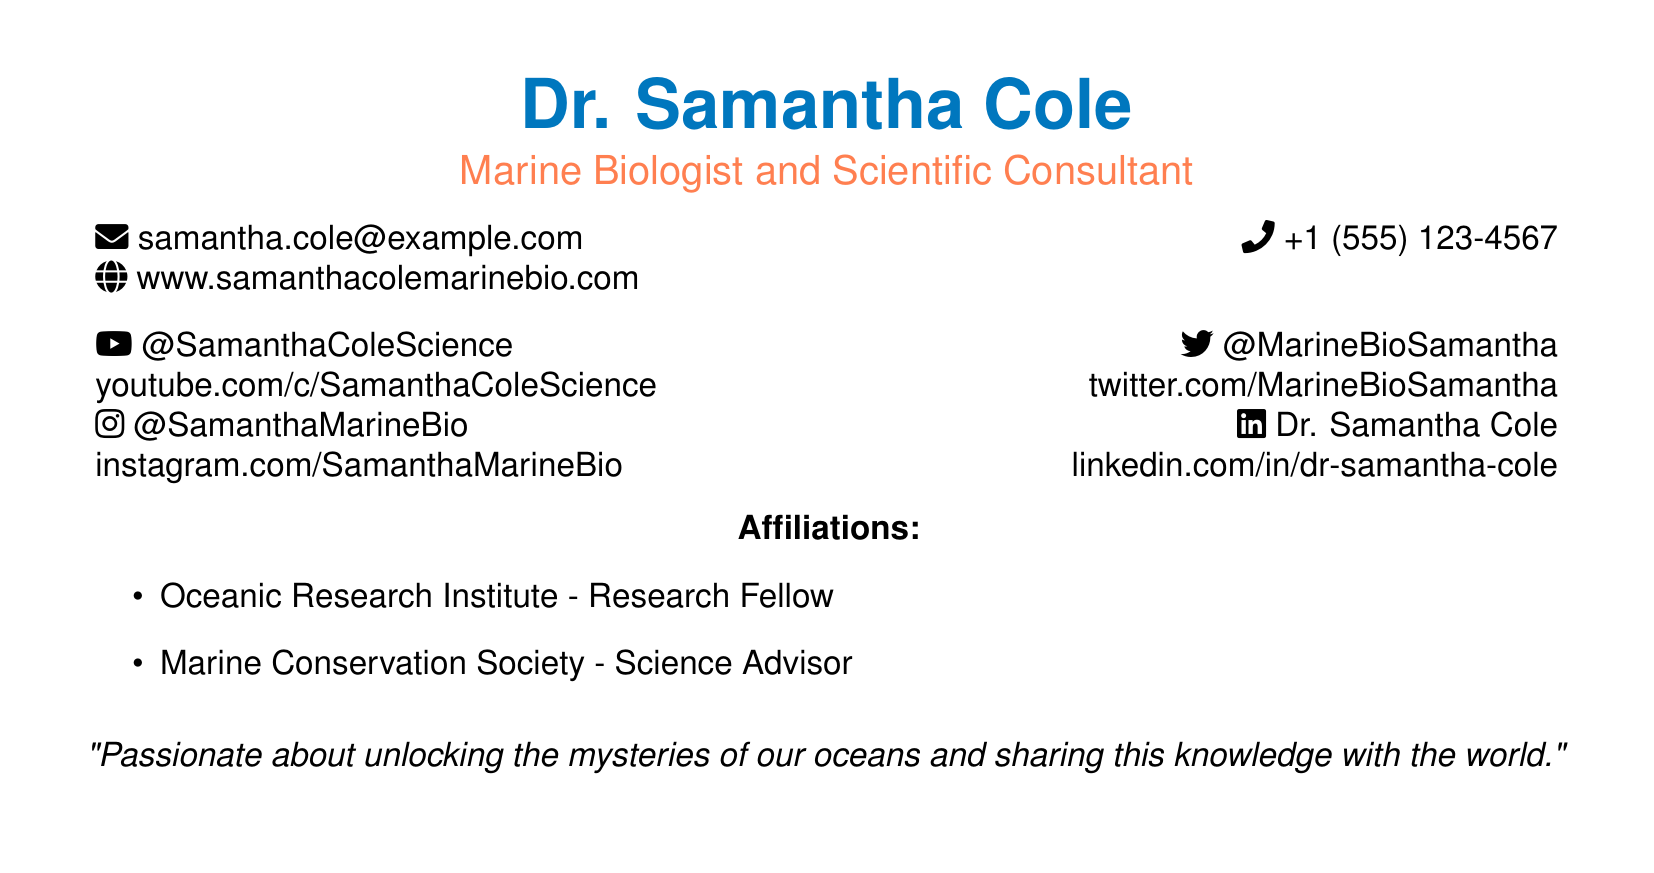What is the name of the marine biologist? The name is prominently displayed at the top of the document.
Answer: Dr. Samantha Cole What is the email address listed? The email address is located in the contact information section.
Answer: samantha.cole@example.com What is Dr. Samantha Cole's YouTube channel link? The YouTube channel link is found in the social media handles section.
Answer: youtube.com/c/SamanthaColeScience Which organization does Dr. Samantha Cole affiliate with as a research fellow? The document specifies affiliations below the contact information.
Answer: Oceanic Research Institute What is Dr. Samantha Cole's Instagram handle? The Instagram handle is included along with other social media links.
Answer: @SamanthaMarineBio How many phone numbers are listed on the card? There is only one phone number provided in the document.
Answer: 1 Which social media platform is mentioned first in the social media section? The social media section includes various platforms, starting from YouTube.
Answer: YouTube What is the profession of Dr. Samantha Cole? The profession is mentioned directly under the name at the top of the document.
Answer: Marine Biologist What is the quote attributed to Dr. Samantha Cole? The quote is located at the bottom of the document.
Answer: "Passionate about unlocking the mysteries of our oceans and sharing this knowledge with the world." 